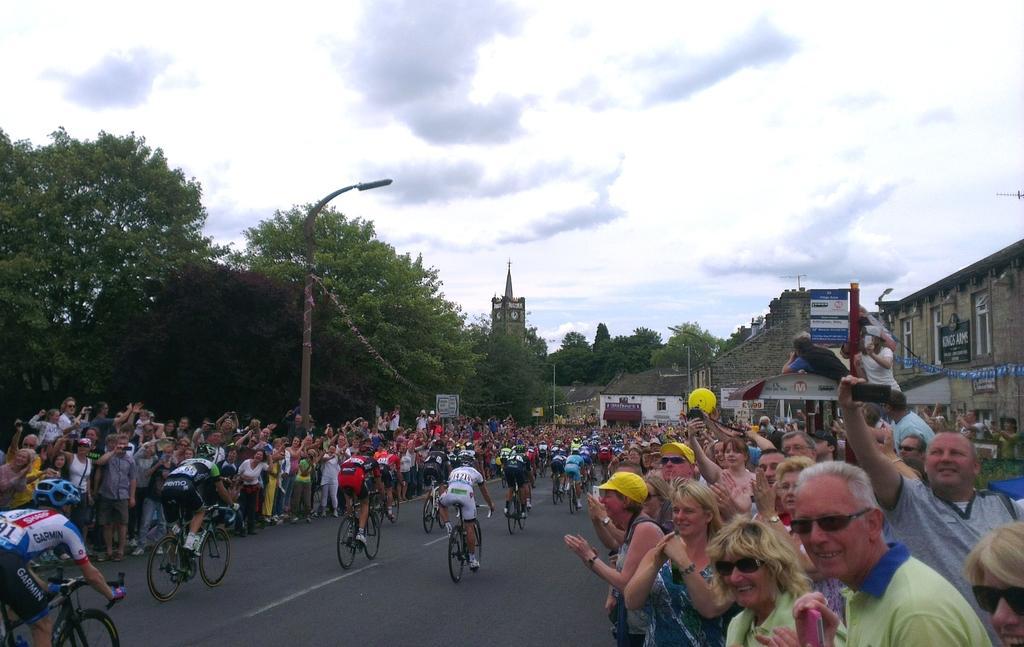Please provide a concise description of this image. In this picture we can see a group of people riding bicycles, the people riding bicycle wore helmets, on the right side and left side of the road there are group of people cheering for them, on the left most of the image we can see a tree and one pole, on the right most of the picture we can see a building, on the top of the picture we can see some clouds and sky. 